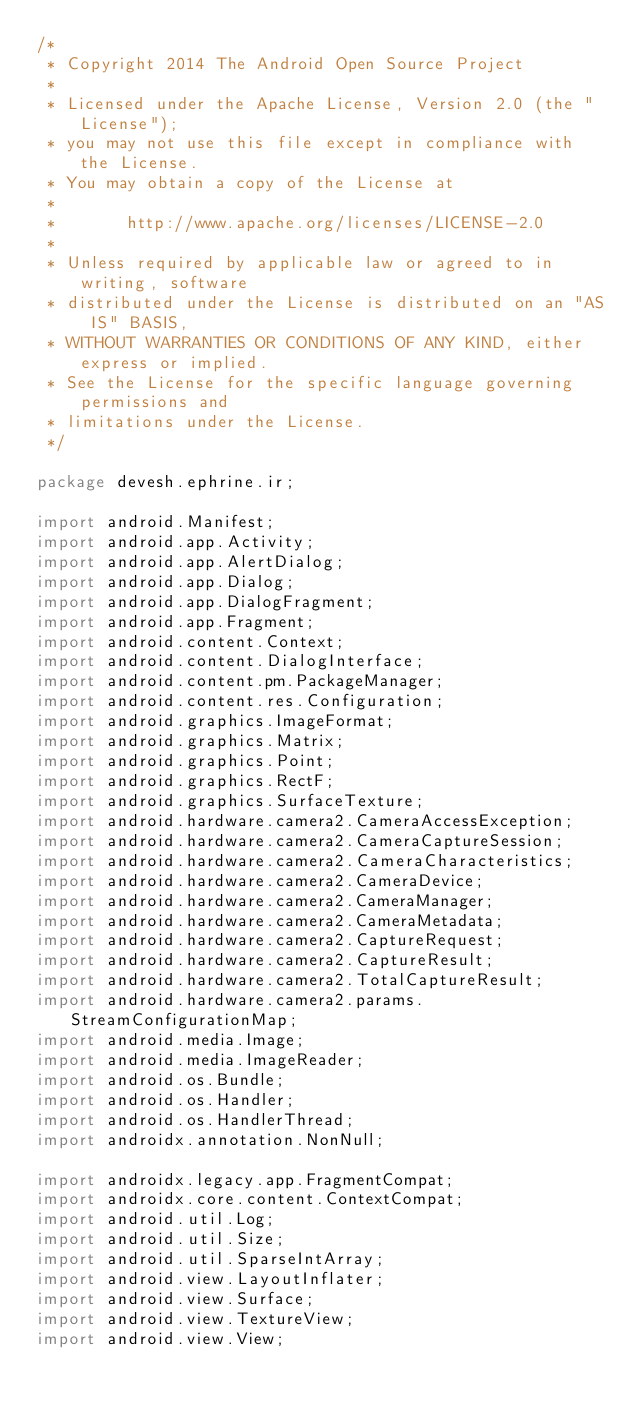<code> <loc_0><loc_0><loc_500><loc_500><_Java_>/*
 * Copyright 2014 The Android Open Source Project
 *
 * Licensed under the Apache License, Version 2.0 (the "License");
 * you may not use this file except in compliance with the License.
 * You may obtain a copy of the License at
 *
 *       http://www.apache.org/licenses/LICENSE-2.0
 *
 * Unless required by applicable law or agreed to in writing, software
 * distributed under the License is distributed on an "AS IS" BASIS,
 * WITHOUT WARRANTIES OR CONDITIONS OF ANY KIND, either express or implied.
 * See the License for the specific language governing permissions and
 * limitations under the License.
 */

package devesh.ephrine.ir;

import android.Manifest;
import android.app.Activity;
import android.app.AlertDialog;
import android.app.Dialog;
import android.app.DialogFragment;
import android.app.Fragment;
import android.content.Context;
import android.content.DialogInterface;
import android.content.pm.PackageManager;
import android.content.res.Configuration;
import android.graphics.ImageFormat;
import android.graphics.Matrix;
import android.graphics.Point;
import android.graphics.RectF;
import android.graphics.SurfaceTexture;
import android.hardware.camera2.CameraAccessException;
import android.hardware.camera2.CameraCaptureSession;
import android.hardware.camera2.CameraCharacteristics;
import android.hardware.camera2.CameraDevice;
import android.hardware.camera2.CameraManager;
import android.hardware.camera2.CameraMetadata;
import android.hardware.camera2.CaptureRequest;
import android.hardware.camera2.CaptureResult;
import android.hardware.camera2.TotalCaptureResult;
import android.hardware.camera2.params.StreamConfigurationMap;
import android.media.Image;
import android.media.ImageReader;
import android.os.Bundle;
import android.os.Handler;
import android.os.HandlerThread;
import androidx.annotation.NonNull;

import androidx.legacy.app.FragmentCompat;
import androidx.core.content.ContextCompat;
import android.util.Log;
import android.util.Size;
import android.util.SparseIntArray;
import android.view.LayoutInflater;
import android.view.Surface;
import android.view.TextureView;
import android.view.View;</code> 